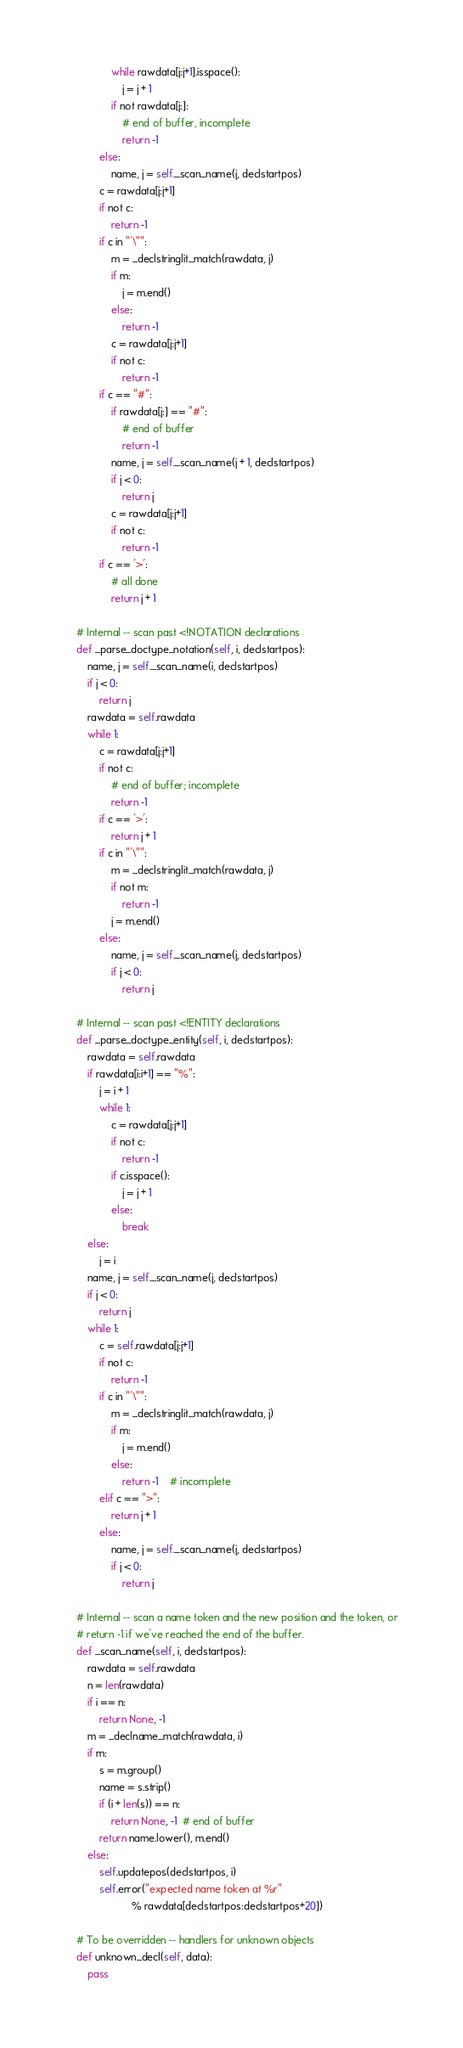<code> <loc_0><loc_0><loc_500><loc_500><_Python_>                while rawdata[j:j+1].isspace():
                    j = j + 1
                if not rawdata[j:]:
                    # end of buffer, incomplete
                    return -1
            else:
                name, j = self._scan_name(j, declstartpos)
            c = rawdata[j:j+1]
            if not c:
                return -1
            if c in "'\"":
                m = _declstringlit_match(rawdata, j)
                if m:
                    j = m.end()
                else:
                    return -1
                c = rawdata[j:j+1]
                if not c:
                    return -1
            if c == "#":
                if rawdata[j:] == "#":
                    # end of buffer
                    return -1
                name, j = self._scan_name(j + 1, declstartpos)
                if j < 0:
                    return j
                c = rawdata[j:j+1]
                if not c:
                    return -1
            if c == '>':
                # all done
                return j + 1

    # Internal -- scan past <!NOTATION declarations
    def _parse_doctype_notation(self, i, declstartpos):
        name, j = self._scan_name(i, declstartpos)
        if j < 0:
            return j
        rawdata = self.rawdata
        while 1:
            c = rawdata[j:j+1]
            if not c:
                # end of buffer; incomplete
                return -1
            if c == '>':
                return j + 1
            if c in "'\"":
                m = _declstringlit_match(rawdata, j)
                if not m:
                    return -1
                j = m.end()
            else:
                name, j = self._scan_name(j, declstartpos)
                if j < 0:
                    return j

    # Internal -- scan past <!ENTITY declarations
    def _parse_doctype_entity(self, i, declstartpos):
        rawdata = self.rawdata
        if rawdata[i:i+1] == "%":
            j = i + 1
            while 1:
                c = rawdata[j:j+1]
                if not c:
                    return -1
                if c.isspace():
                    j = j + 1
                else:
                    break
        else:
            j = i
        name, j = self._scan_name(j, declstartpos)
        if j < 0:
            return j
        while 1:
            c = self.rawdata[j:j+1]
            if not c:
                return -1
            if c in "'\"":
                m = _declstringlit_match(rawdata, j)
                if m:
                    j = m.end()
                else:
                    return -1    # incomplete
            elif c == ">":
                return j + 1
            else:
                name, j = self._scan_name(j, declstartpos)
                if j < 0:
                    return j

    # Internal -- scan a name token and the new position and the token, or
    # return -1 if we've reached the end of the buffer.
    def _scan_name(self, i, declstartpos):
        rawdata = self.rawdata
        n = len(rawdata)
        if i == n:
            return None, -1
        m = _declname_match(rawdata, i)
        if m:
            s = m.group()
            name = s.strip()
            if (i + len(s)) == n:
                return None, -1  # end of buffer
            return name.lower(), m.end()
        else:
            self.updatepos(declstartpos, i)
            self.error("expected name token at %r"
                       % rawdata[declstartpos:declstartpos+20])

    # To be overridden -- handlers for unknown objects
    def unknown_decl(self, data):
        pass
</code> 